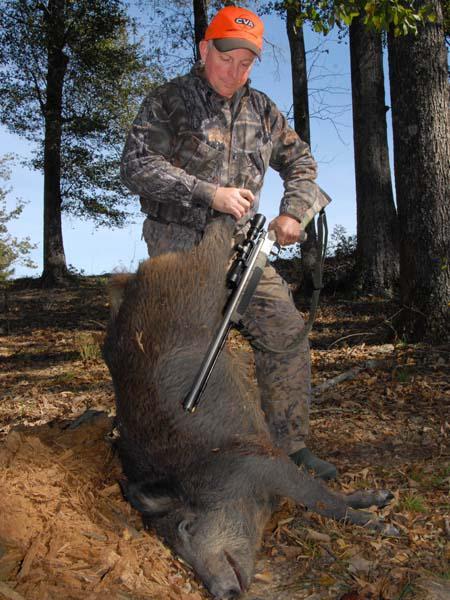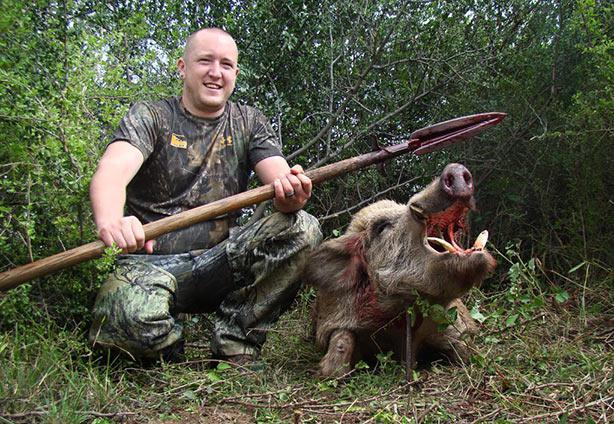The first image is the image on the left, the second image is the image on the right. Assess this claim about the two images: "there is a dead boar with it's mouth wide open and a man with a long blade spear sitting behind it". Correct or not? Answer yes or no. Yes. The first image is the image on the left, the second image is the image on the right. Considering the images on both sides, is "A male person grasping a spear in both hands is by a killed hog positioned on the ground with its open-mouthed face toward the camera." valid? Answer yes or no. Yes. 